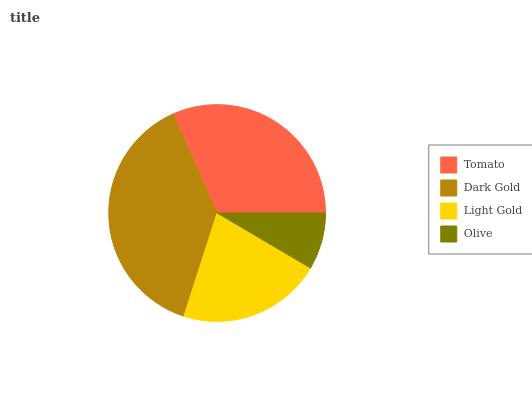Is Olive the minimum?
Answer yes or no. Yes. Is Dark Gold the maximum?
Answer yes or no. Yes. Is Light Gold the minimum?
Answer yes or no. No. Is Light Gold the maximum?
Answer yes or no. No. Is Dark Gold greater than Light Gold?
Answer yes or no. Yes. Is Light Gold less than Dark Gold?
Answer yes or no. Yes. Is Light Gold greater than Dark Gold?
Answer yes or no. No. Is Dark Gold less than Light Gold?
Answer yes or no. No. Is Tomato the high median?
Answer yes or no. Yes. Is Light Gold the low median?
Answer yes or no. Yes. Is Light Gold the high median?
Answer yes or no. No. Is Tomato the low median?
Answer yes or no. No. 